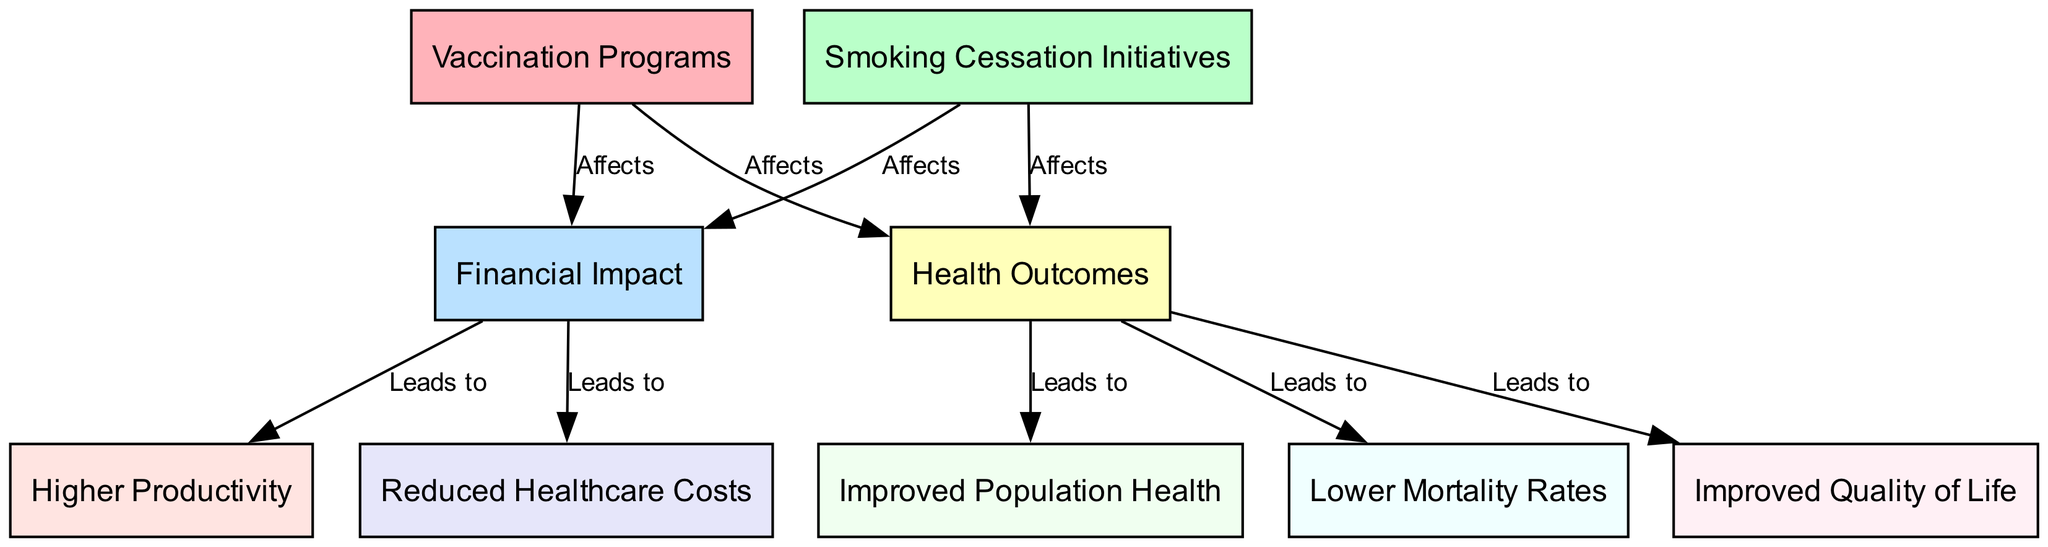What nodes are present in the diagram? The diagram contains the following nodes: Vaccination Programs, Smoking Cessation Initiatives, Financial Impact, Health Outcomes, Reduced Healthcare Costs, Improved Population Health, Higher Productivity, Lower Mortality Rates, and Improved Quality of Life. Each one is listed as part of the node data.
Answer: Vaccination Programs, Smoking Cessation Initiatives, Financial Impact, Health Outcomes, Reduced Healthcare Costs, Improved Population Health, Higher Productivity, Lower Mortality Rates, Improved Quality of Life How many edges are in the diagram? The diagram comprises eight edges that connect different nodes. The connection information is provided in the edges data, which shows the relationships between the respective nodes.
Answer: Eight edges What does the "Financial Impact" node lead to? The "Financial Impact" node leads to Reduced Healthcare Costs and Higher Productivity. As per the edge relationships, these two nodes have directed edges coming from the Financial Impact node.
Answer: Reduced Healthcare Costs, Higher Productivity What affects health outcomes according to the diagram? Both Vaccination Programs and Smoking Cessation Initiatives affect health outcomes as indicated by the directed edges originating from these nodes towards the Health Outcomes node.
Answer: Vaccination Programs, Smoking Cessation Initiatives Which outcome is connected to "Improved Population Health"? The "Improved Population Health" node is connected to "Health Outcomes", which leads to it based on the pathways indicated by the diagram. This relationship shows that better health outcomes contribute to improved population health.
Answer: Health Outcomes What is the relationship between "Smoking Cessation Initiatives" and "Lower Mortality Rates"? The relationship indicates that Smoking Cessation Initiatives affect health outcomes, which leads to lower mortality rates, establishing a causal pathway from the intervention to the health outcome.
Answer: Affects What are the health outcomes influenced by the interventions? The interventions influence several health outcomes: Improved Population Health, Lower Mortality Rates, and Improved Quality of Life, all of which are directly linked through the paths established in the diagram.
Answer: Improved Population Health, Lower Mortality Rates, Improved Quality of Life What does the edge from "Vaccination Programs" to "Financial Impact" represent? The edge from "Vaccination Programs" to "Financial Impact" represents a direct influence, indicating that vaccination programs have a financial impact according to the structure of the diagram, establishing a causal link.
Answer: Affects 